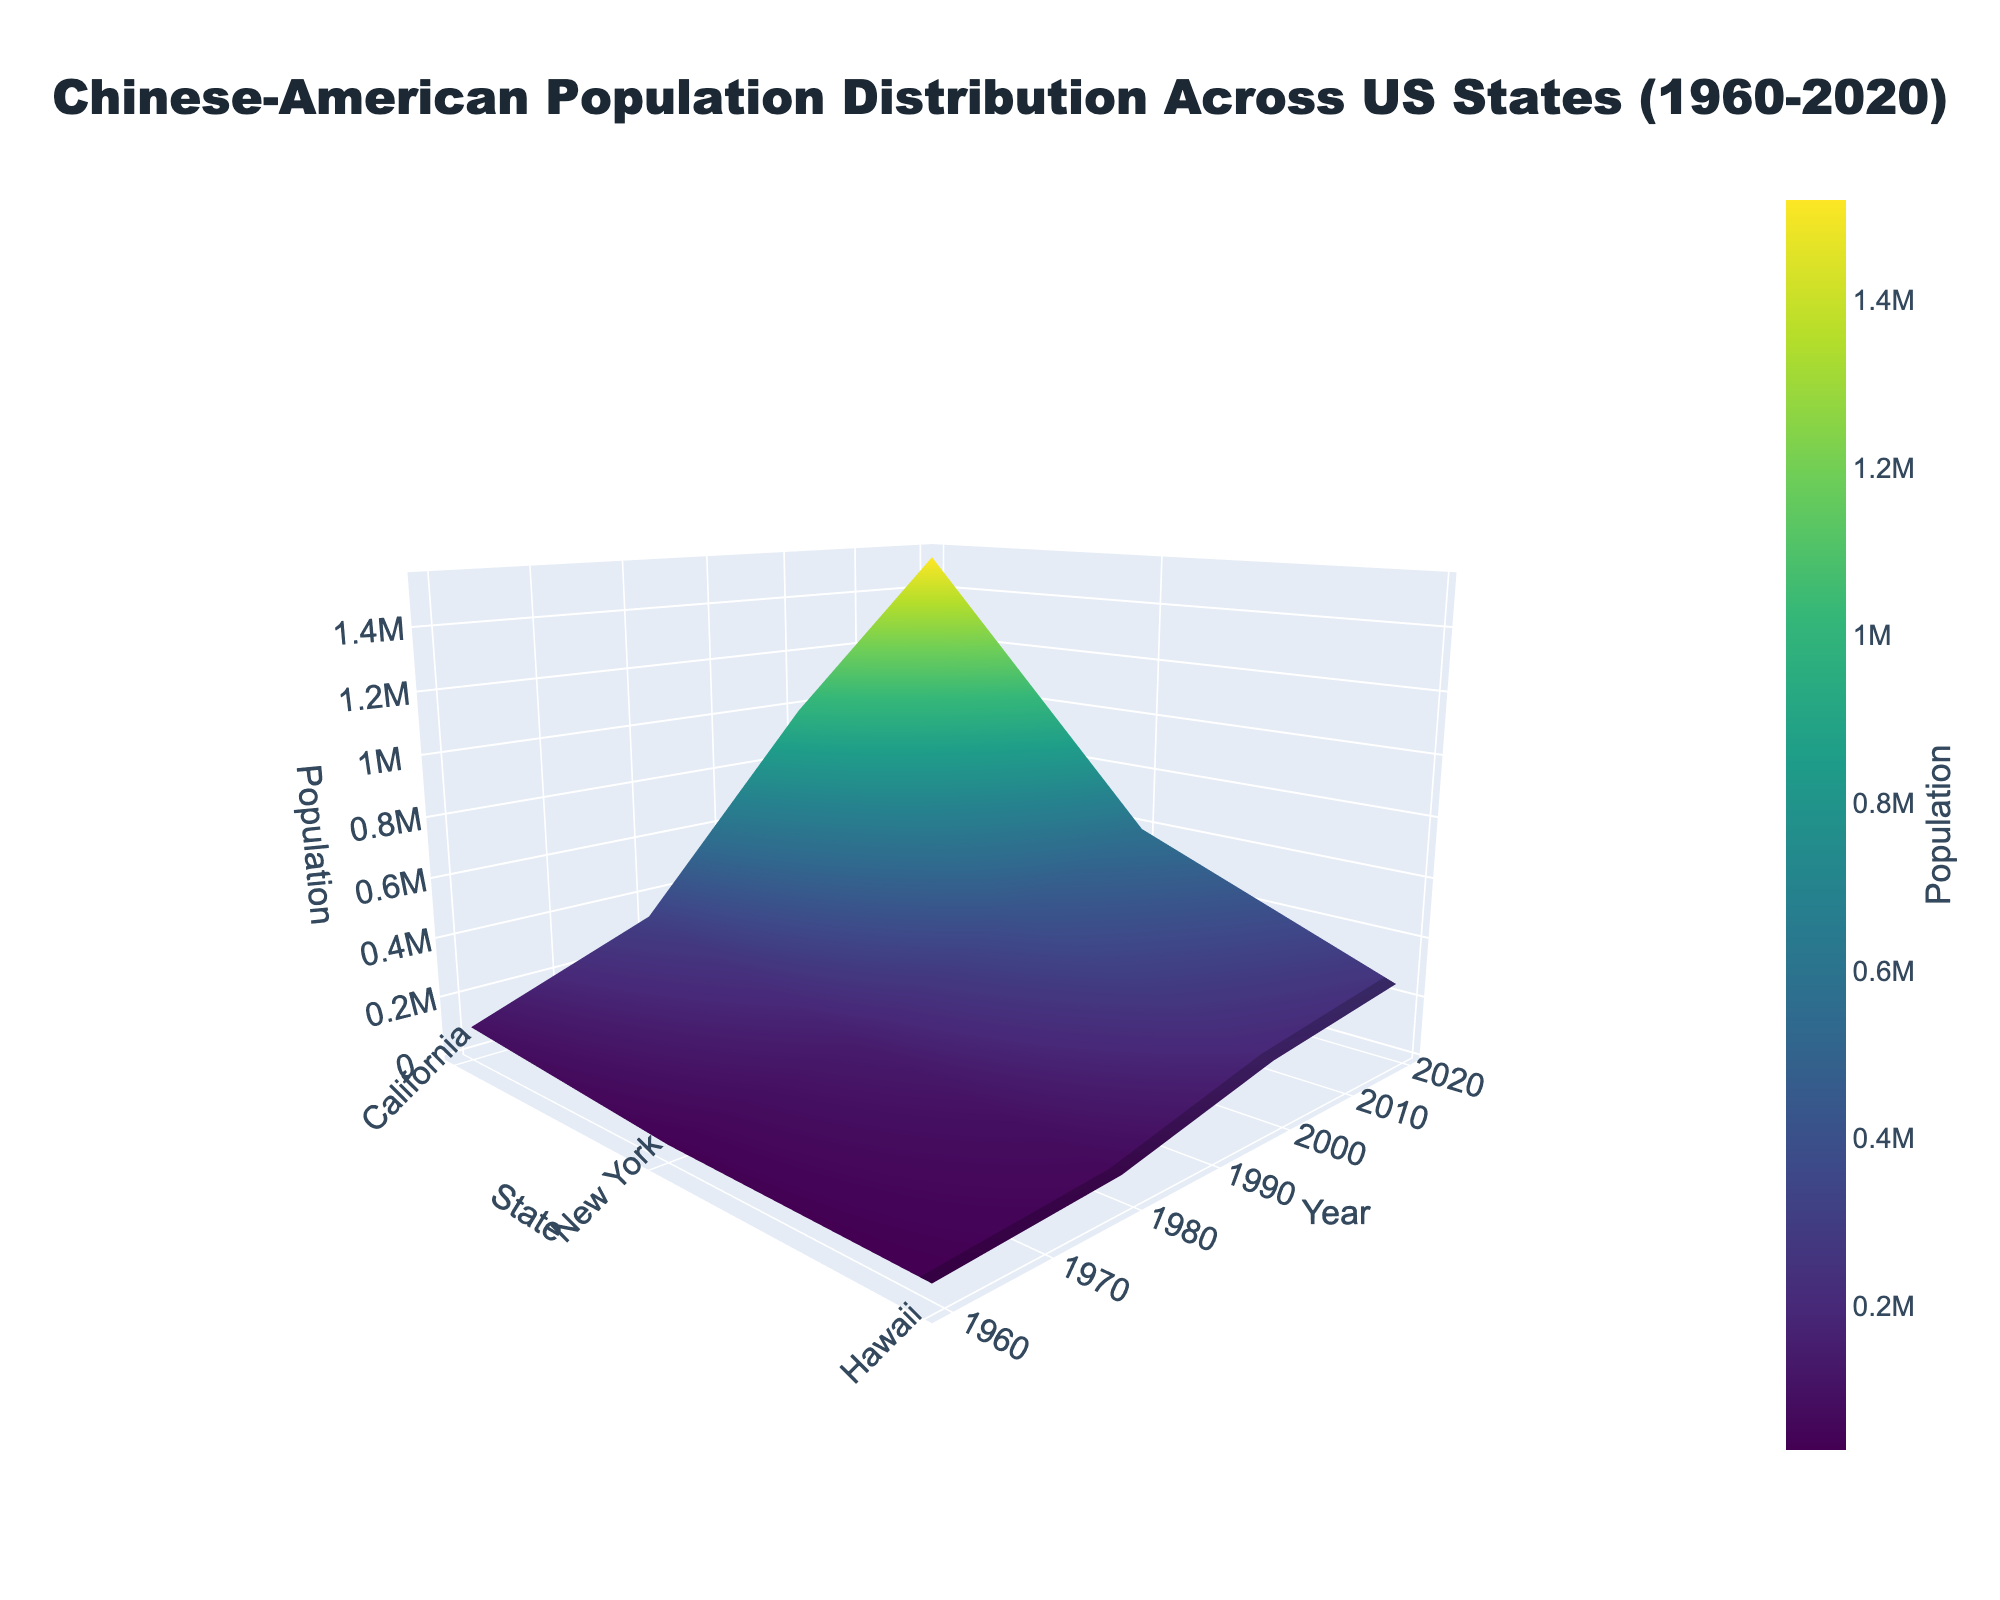What is the title of the figure? The title is usually displayed prominently at the top of the figure. Look at the center top to find it.
Answer: Chinese-American Population Distribution Across US States (1960-2020) Which state had the highest Chinese-American population in 2020? Observe the population values for different states in the year 2020. The tallest bar in 2020 indicates the state with the highest population.
Answer: California How did the Chinese-American population in New York change from 1960 to 2020? Compare the height of the New York columns from 1960 to 2020 to see the changes. Calculate the difference between the values.
Answer: Increased by 549,000 Which year shows the highest overall Chinese-American population across all states? Look at the height of the columns for all states across different years. The year with the tallest columns overall indicates the highest population.
Answer: 2020 Between California and Hawaii, which state had the larger population increase between 1980 and 2000? Compare the population difference for both states between 1980 and 2000. Subtract 1980 values from 2000 values and compare.
Answer: California (658,000 increase) What are the axes titles for the figure? The axes titles can be found along the three major axes. Look for the labeled text around the plot edges.
Answer: State, Year, Population Is there a state that shows a decreasing Chinese-American population over time? Check for any state where the population height decreases from one year to the next along the years.
Answer: No Which state had the smallest Chinese-American population in 1980? Look at the height of the columns in the year 1980 and identify the shortest one.
Answer: Hawaii How many states are represented in the year 2020? Count the number of columns present for the year 2020. Each column represents a state.
Answer: Five What trend can be observed in California’s Chinese-American population from 1960 to 2020? Observe the heights of the columns for California across all years and describe the trend.
Answer: Increasing trend 